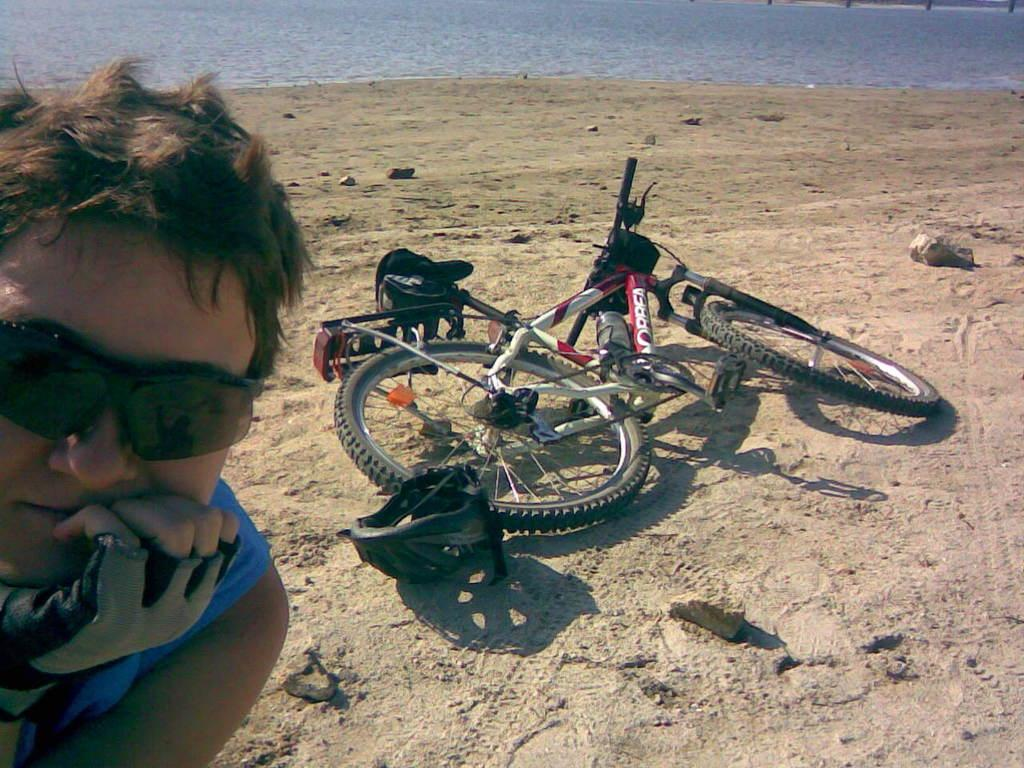What is the main object in the center of the image? There is a bicycle in the center of the image. Can you describe the person on the left side of the image? There is a person wearing glasses on the left side of the image. What can be seen in the background of the image? There is water visible in the background of the image. What type of terrain is at the bottom of the image? There is sand at the bottom of the image. What type of hammer is the person using to tell a story in the image? There is no hammer or storytelling depicted in the image; it features a bicycle and a person wearing glasses. 